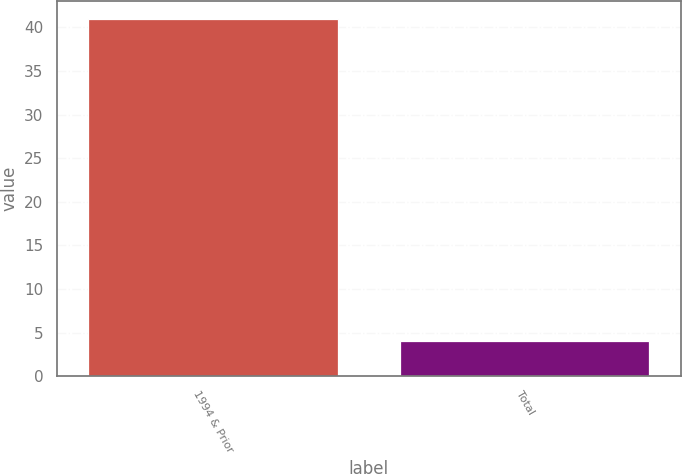<chart> <loc_0><loc_0><loc_500><loc_500><bar_chart><fcel>1994 & Prior<fcel>Total<nl><fcel>41<fcel>4<nl></chart> 